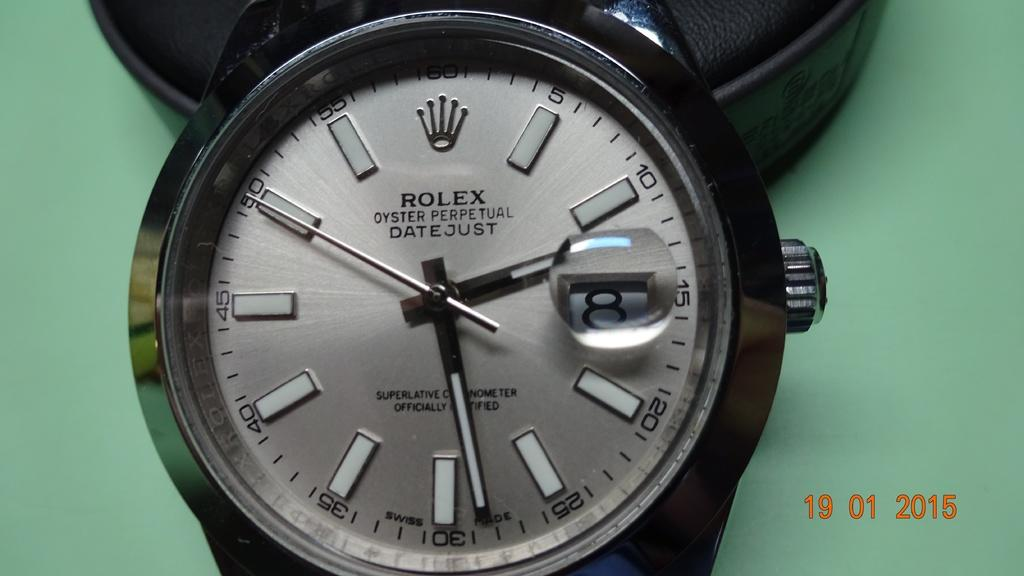<image>
Provide a brief description of the given image. A rolex watch is shown in a picture that was taken in 2015. 